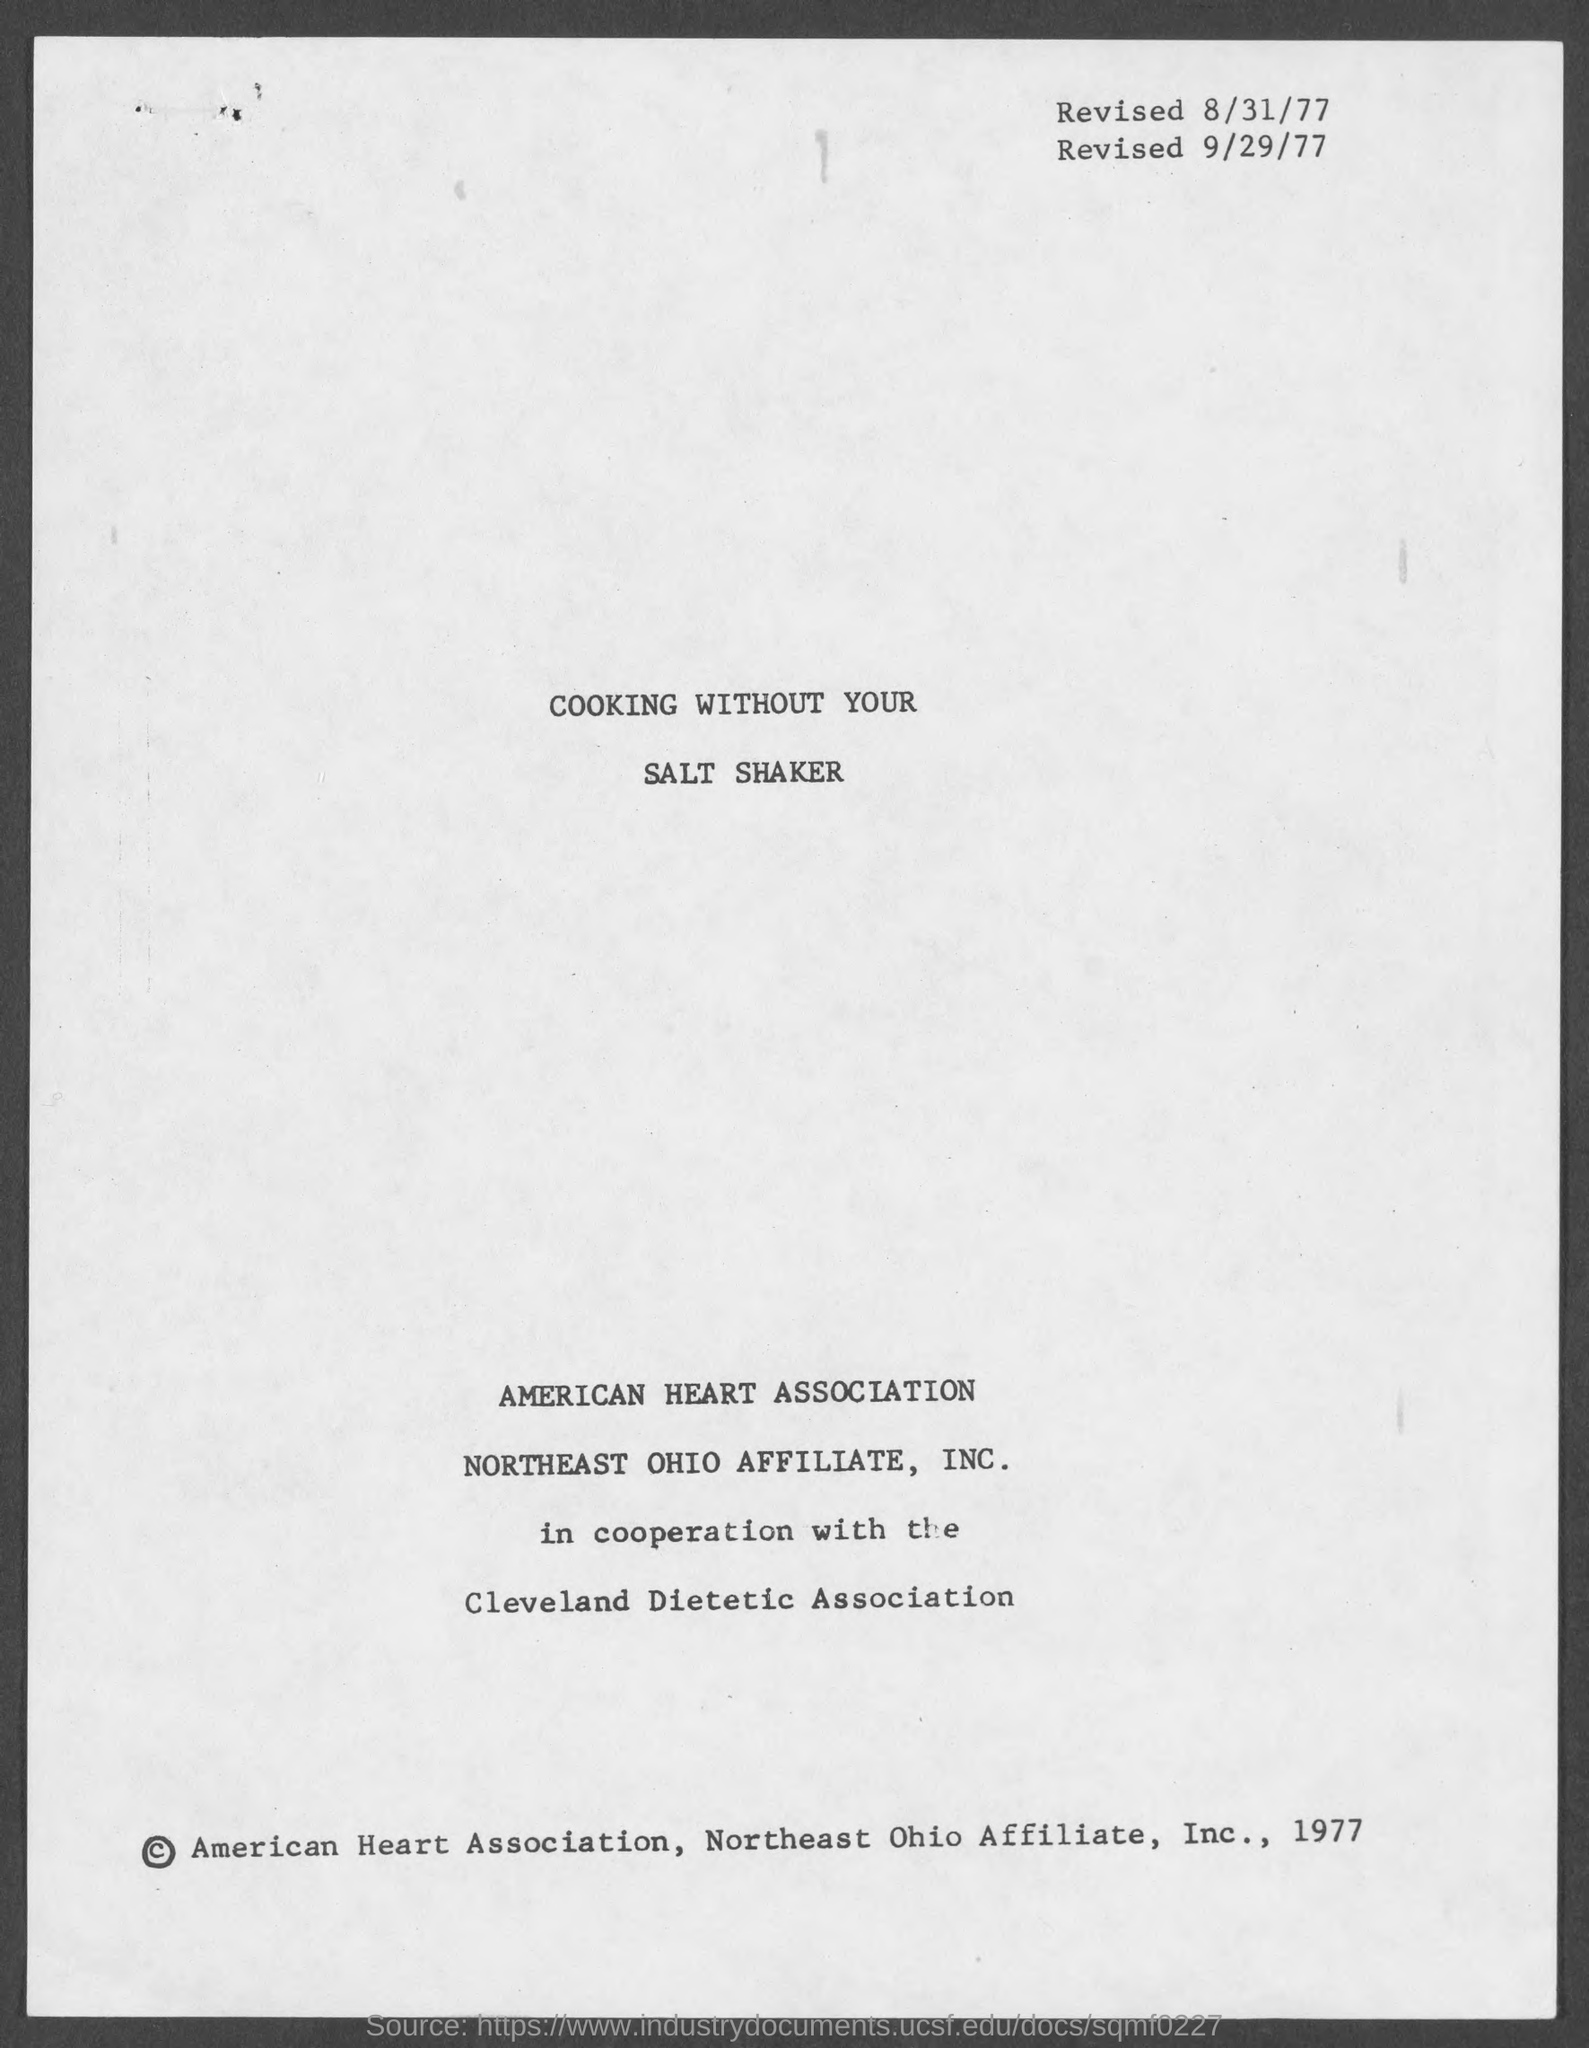Draw attention to some important aspects in this diagram. What is the first revised date? It is 8/31/77. The title of the document is 'Cooking Without Your Salt Shaker.' The second revised date is September 29, 1977. 